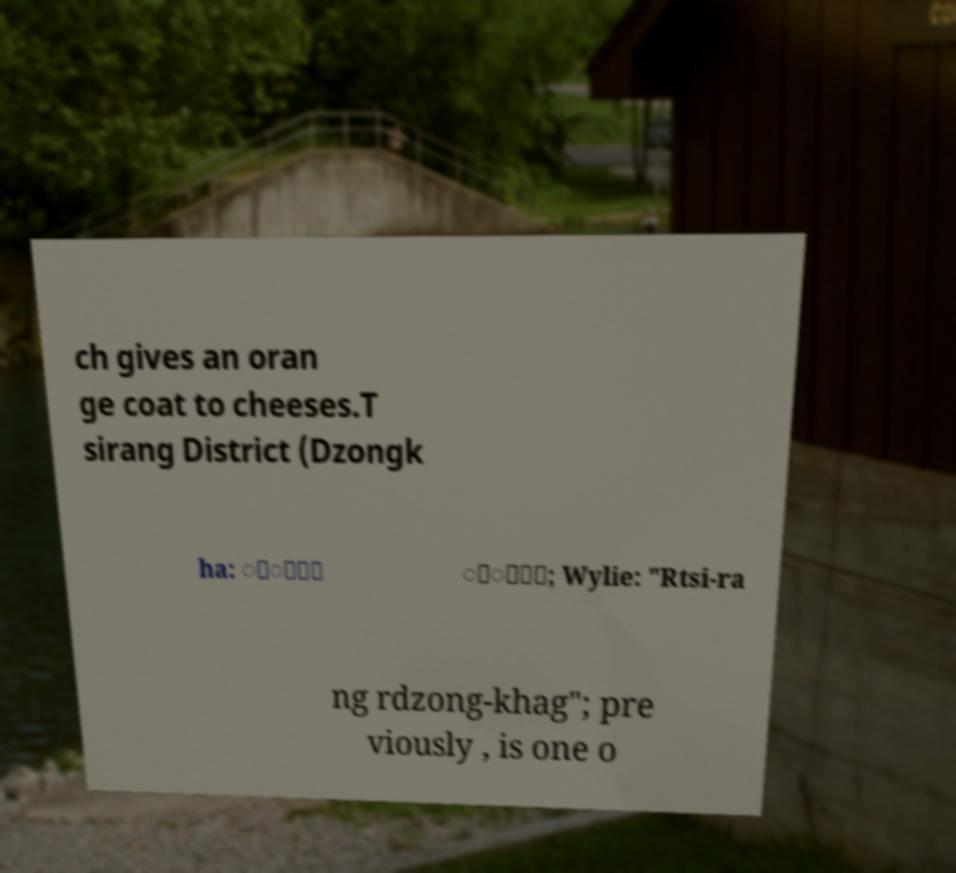Can you accurately transcribe the text from the provided image for me? ch gives an oran ge coat to cheeses.T sirang District (Dzongk ha: ྩི་་ ྫོ་་; Wylie: "Rtsi-ra ng rdzong-khag"; pre viously , is one o 